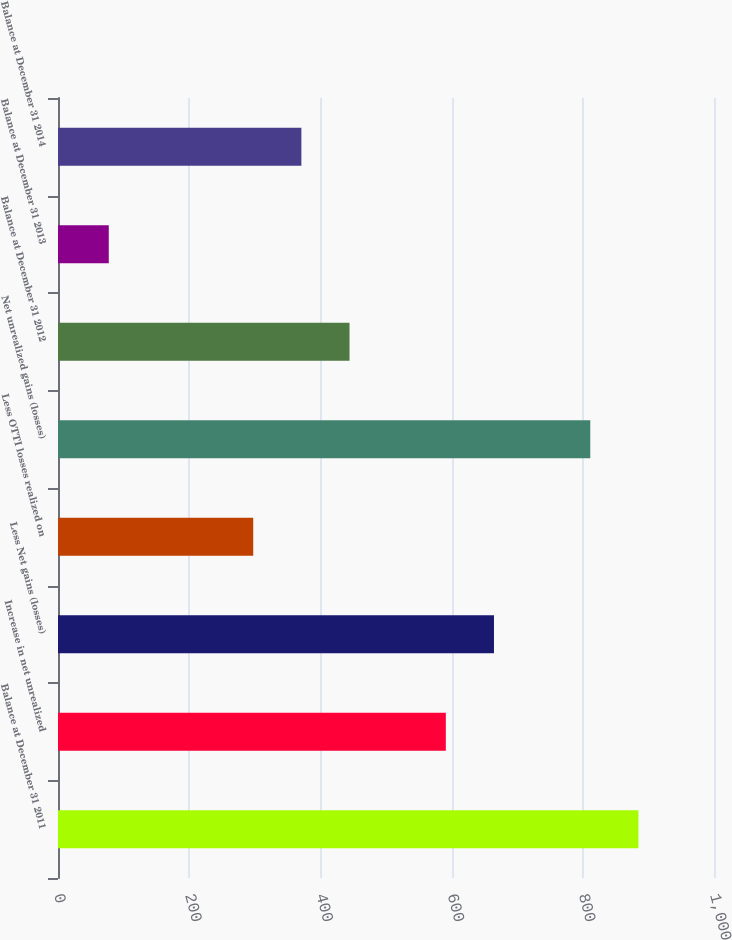<chart> <loc_0><loc_0><loc_500><loc_500><bar_chart><fcel>Balance at December 31 2011<fcel>Increase in net unrealized<fcel>Less Net gains (losses)<fcel>Less OTTI losses realized on<fcel>Net unrealized gains (losses)<fcel>Balance at December 31 2012<fcel>Balance at December 31 2013<fcel>Balance at December 31 2014<nl><fcel>884.8<fcel>591.2<fcel>664.6<fcel>297.6<fcel>811.4<fcel>444.4<fcel>77.4<fcel>371<nl></chart> 